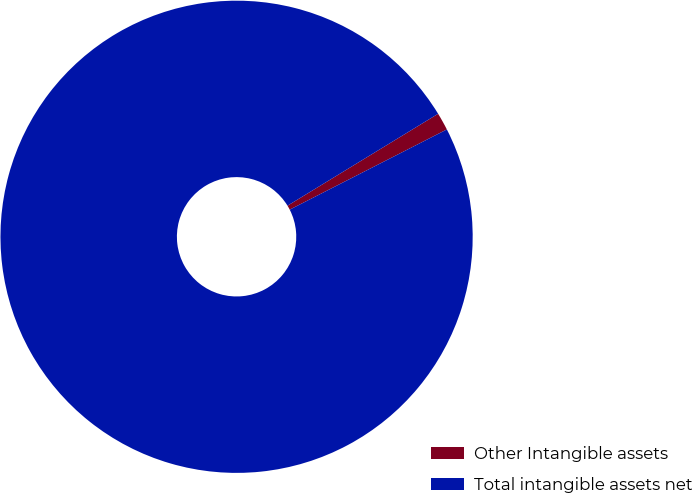Convert chart. <chart><loc_0><loc_0><loc_500><loc_500><pie_chart><fcel>Other Intangible assets<fcel>Total intangible assets net<nl><fcel>1.21%<fcel>98.79%<nl></chart> 